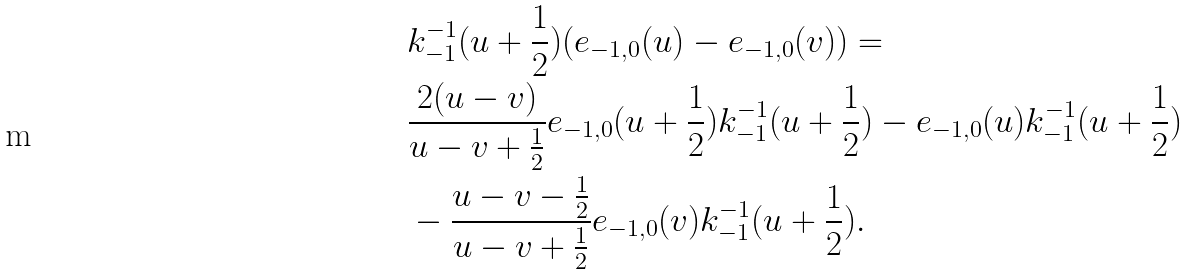<formula> <loc_0><loc_0><loc_500><loc_500>& k ^ { - 1 } _ { - 1 } ( u + \frac { 1 } { 2 } ) ( e _ { - 1 , 0 } ( u ) - e _ { - 1 , 0 } ( v ) ) = \\ & \frac { 2 ( u - v ) } { u - v + \frac { 1 } { 2 } } e _ { - 1 , 0 } ( u + \frac { 1 } { 2 } ) k ^ { - 1 } _ { - 1 } ( u + \frac { 1 } { 2 } ) - e _ { - 1 , 0 } ( u ) k ^ { - 1 } _ { - 1 } ( u + \frac { 1 } { 2 } ) \\ & - \frac { u - v - \frac { 1 } { 2 } } { u - v + \frac { 1 } { 2 } } e _ { - 1 , 0 } ( v ) k ^ { - 1 } _ { - 1 } ( u + \frac { 1 } { 2 } ) .</formula> 